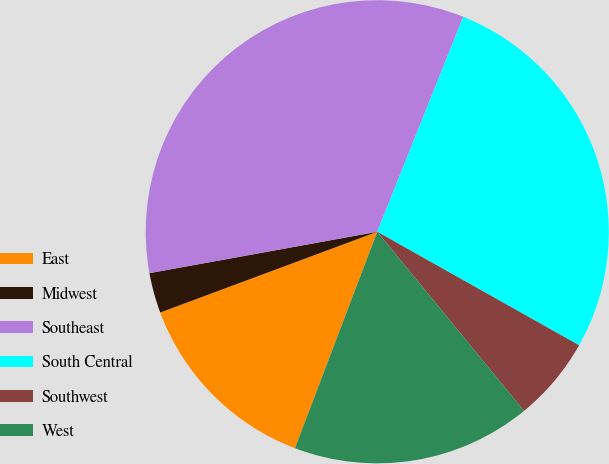<chart> <loc_0><loc_0><loc_500><loc_500><pie_chart><fcel>East<fcel>Midwest<fcel>Southeast<fcel>South Central<fcel>Southwest<fcel>West<nl><fcel>13.55%<fcel>2.81%<fcel>33.92%<fcel>27.1%<fcel>5.92%<fcel>16.71%<nl></chart> 